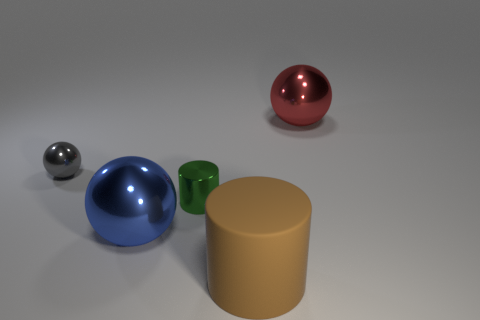Is there a small gray object of the same shape as the large brown thing?
Make the answer very short. No. How many other things are the same color as the small sphere?
Your answer should be very brief. 0. Is the number of red metallic things that are to the right of the green shiny cylinder less than the number of small gray spheres?
Give a very brief answer. No. What number of small metal balls are there?
Offer a very short reply. 1. How many small green things have the same material as the gray sphere?
Provide a short and direct response. 1. How many things are either gray metallic balls that are on the left side of the brown cylinder or tiny red shiny cubes?
Offer a very short reply. 1. Are there fewer green cylinders in front of the large blue ball than small metal balls that are in front of the gray shiny sphere?
Keep it short and to the point. No. Are there any metal balls behind the gray metal ball?
Offer a terse response. Yes. What number of objects are gray metal balls on the left side of the large brown object or large metallic spheres that are right of the small green object?
Provide a short and direct response. 2. How many small metal things are the same color as the large cylinder?
Give a very brief answer. 0. 